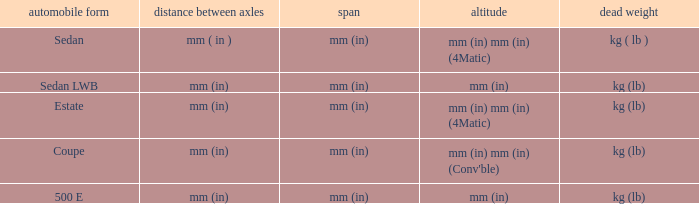What's the curb weight of the model with a wheelbase of mm (in) and height of mm (in) mm (in) (4Matic)? Kg ( lb ), kg (lb). 